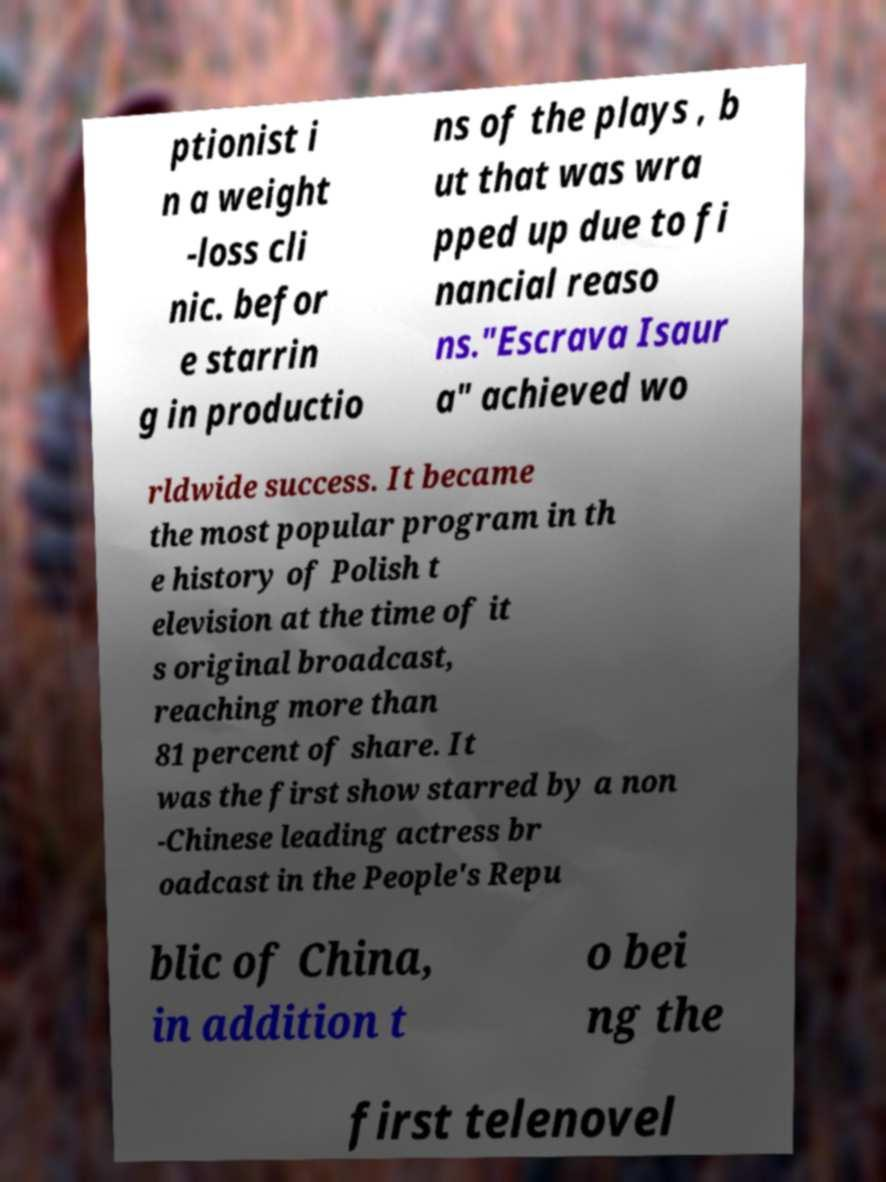Could you extract and type out the text from this image? ptionist i n a weight -loss cli nic. befor e starrin g in productio ns of the plays , b ut that was wra pped up due to fi nancial reaso ns."Escrava Isaur a" achieved wo rldwide success. It became the most popular program in th e history of Polish t elevision at the time of it s original broadcast, reaching more than 81 percent of share. It was the first show starred by a non -Chinese leading actress br oadcast in the People's Repu blic of China, in addition t o bei ng the first telenovel 